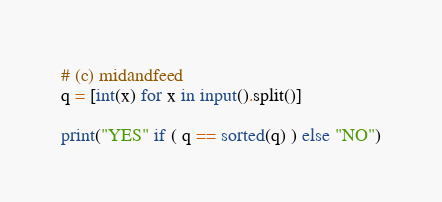<code> <loc_0><loc_0><loc_500><loc_500><_Python_># (c) midandfeed
q = [int(x) for x in input().split()]

print("YES" if ( q == sorted(q) ) else "NO")</code> 